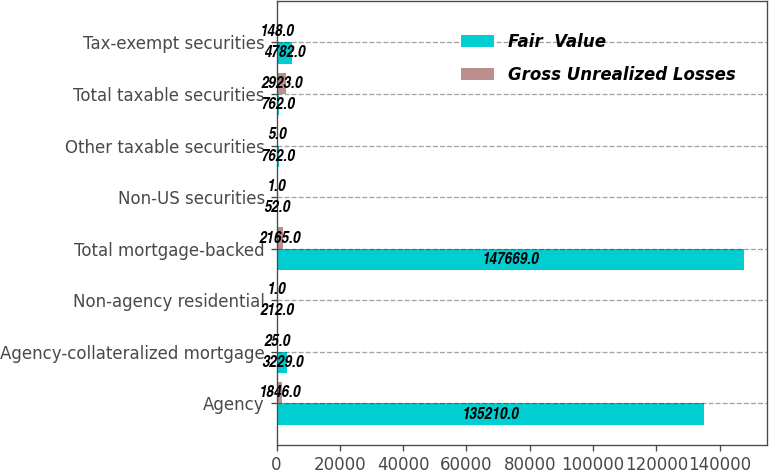<chart> <loc_0><loc_0><loc_500><loc_500><stacked_bar_chart><ecel><fcel>Agency<fcel>Agency-collateralized mortgage<fcel>Non-agency residential<fcel>Total mortgage-backed<fcel>Non-US securities<fcel>Other taxable securities<fcel>Total taxable securities<fcel>Tax-exempt securities<nl><fcel>Fair  Value<fcel>135210<fcel>3229<fcel>212<fcel>147669<fcel>52<fcel>762<fcel>762<fcel>4782<nl><fcel>Gross Unrealized Losses<fcel>1846<fcel>25<fcel>1<fcel>2165<fcel>1<fcel>5<fcel>2923<fcel>148<nl></chart> 